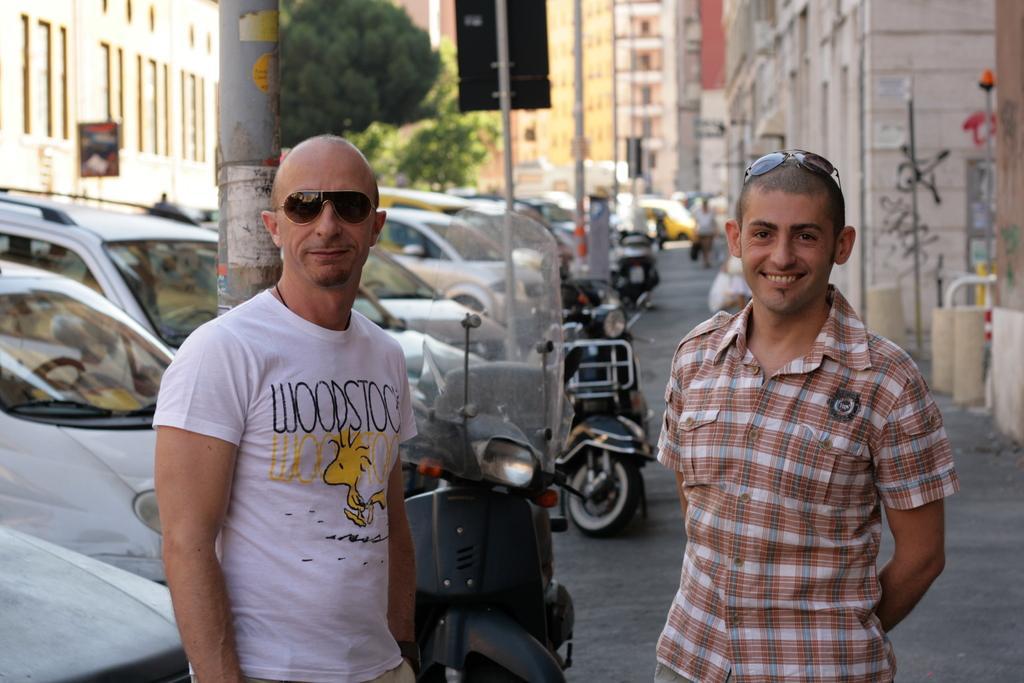Please provide a concise description of this image. On the left side of the image there is a man with white t-shirt is standing and he kept goggles. Behind him there is a pole and also there are many cars. And on the right side of the image there is a man with checks shirt is standing and he kept goggles on his head. Behind them there is a footpath with few bikes. In the background there are many poles, trees and buildings. 